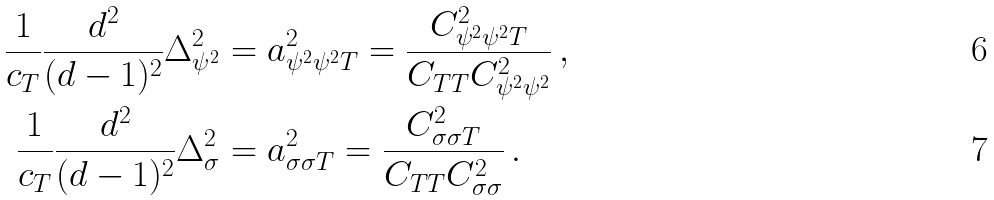<formula> <loc_0><loc_0><loc_500><loc_500>\frac { 1 } { c _ { T } } \frac { d ^ { 2 } } { ( d - 1 ) ^ { 2 } } \Delta _ { \psi ^ { 2 } } ^ { 2 } & = a _ { \psi ^ { 2 } \psi ^ { 2 } T } ^ { 2 } = \frac { C _ { \psi ^ { 2 } \psi ^ { 2 } T } ^ { 2 } } { C _ { T T } C _ { \psi ^ { 2 } \psi ^ { 2 } } ^ { 2 } } \, , \\ \frac { 1 } { c _ { T } } \frac { d ^ { 2 } } { ( d - 1 ) ^ { 2 } } \Delta _ { \sigma } ^ { 2 } & = a _ { \sigma \sigma T } ^ { 2 } = \frac { C _ { \sigma \sigma T } ^ { 2 } } { C _ { T T } C _ { \sigma \sigma } ^ { 2 } } \, .</formula> 